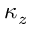Convert formula to latex. <formula><loc_0><loc_0><loc_500><loc_500>\kappa _ { z }</formula> 